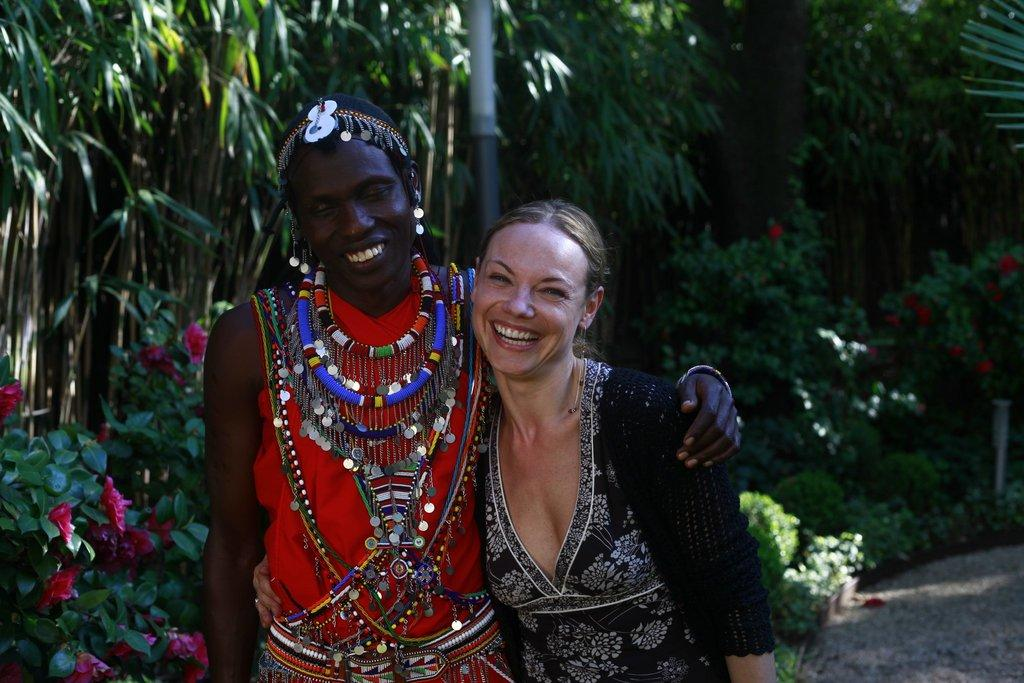How many people are in the image? There are two people in the image. What colors are the people wearing? The people are wearing black, white, and red color dresses. What can be seen in the background of the image? There are plants and trees in the background of the image. What type of flowers are on the plants? There are red color flowers on the plants. What time of day is it in the image, and how does the morning light affect the head of the person on the left? The provided facts do not mention the time of day or any specific details about the lighting or the person's head. Therefore, we cannot answer this question based on the given information. 